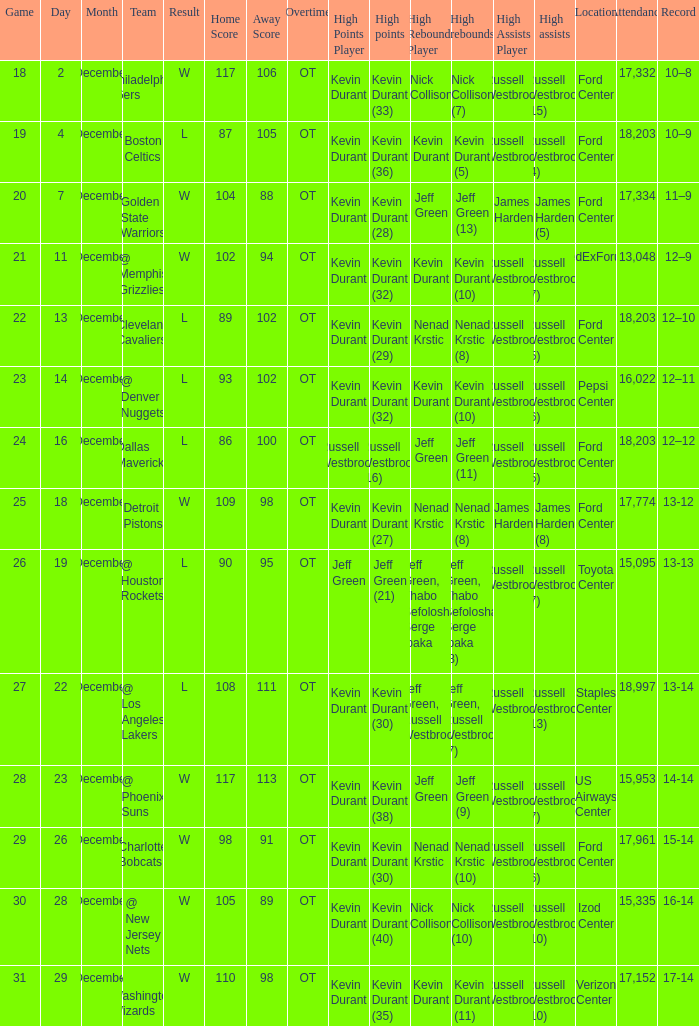Who has high points when verizon center 17,152 is location attendance? Kevin Durant (35). 